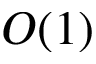<formula> <loc_0><loc_0><loc_500><loc_500>O ( 1 )</formula> 